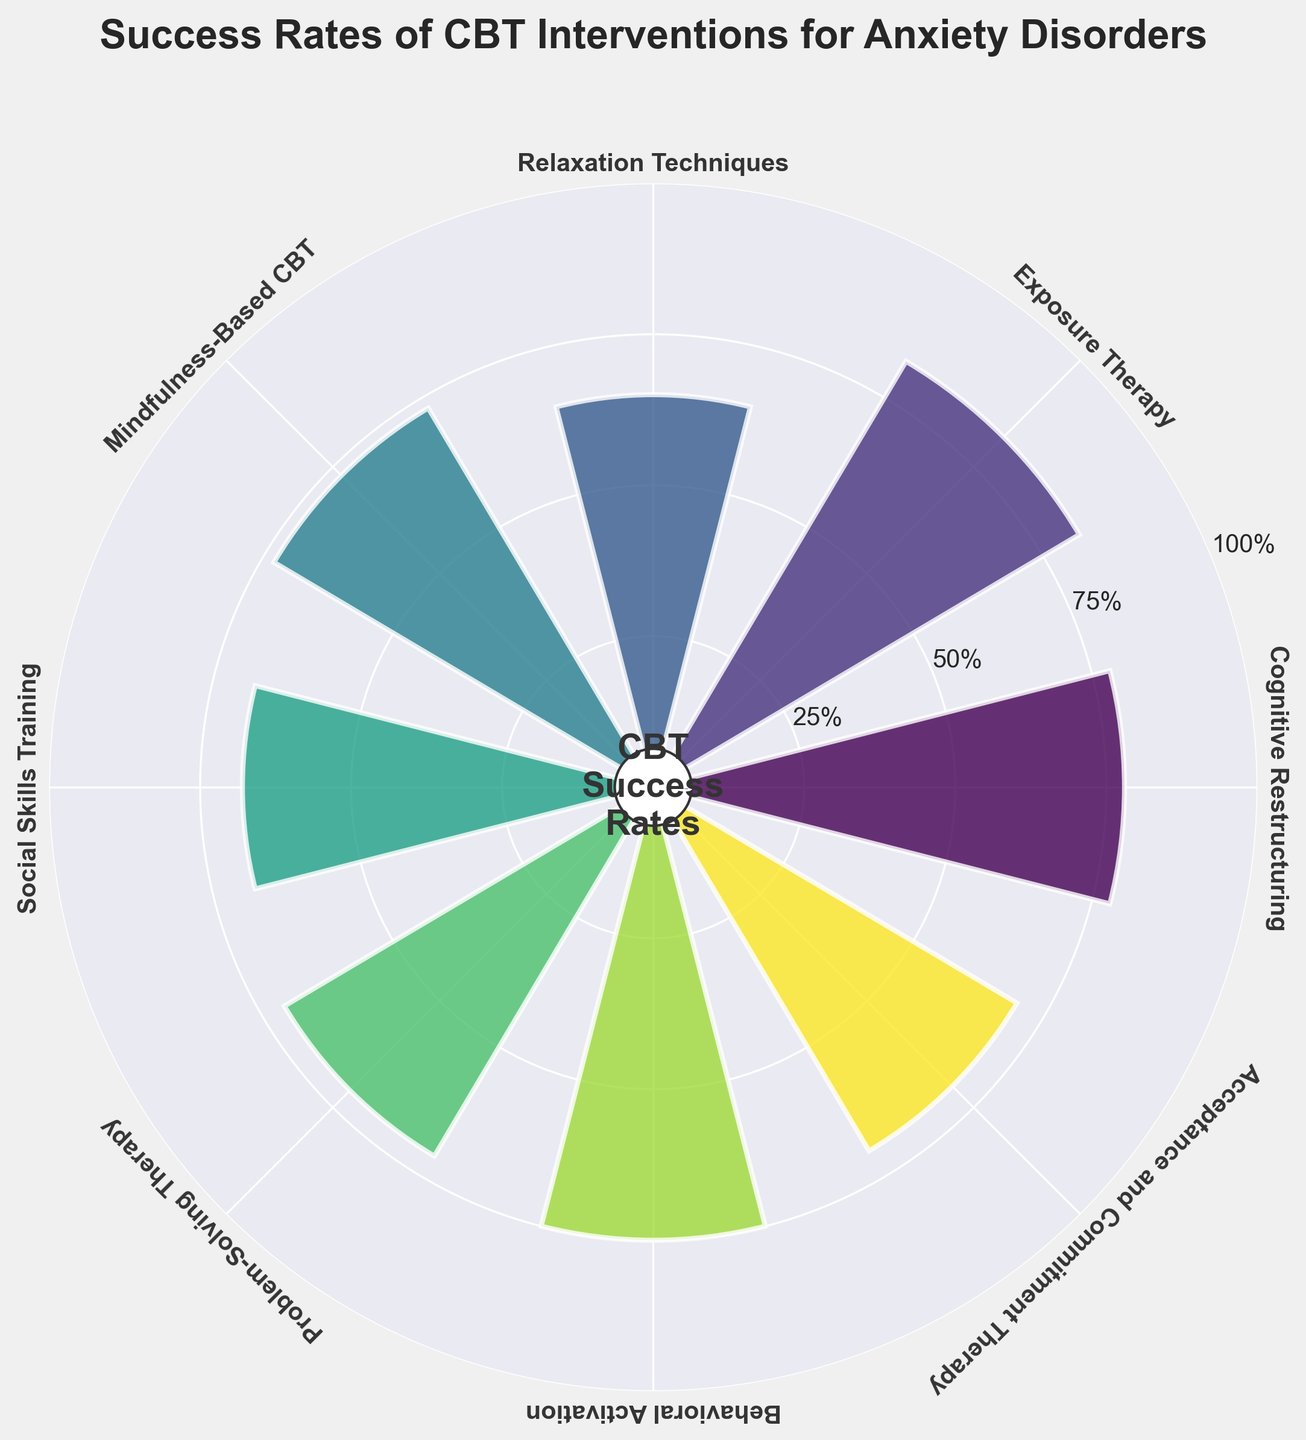What is the title of the gauge chart? The title is the descriptive heading at the top of the figure that summarizes the content of the chart. In this chart, it is bold and located above the chart.
Answer: Success Rates of CBT Interventions for Anxiety Disorders Which CBT intervention has the highest success rate? To find the highest success rate, you look for the label associated with the largest segment of the chart. In this case, the largest bar in the gauge at the highest position indicates the highest success rate.
Answer: Exposure Therapy What is the success rate of Relaxation Techniques? Look at the segment labeled "Relaxation Techniques" and check the length of the bar extending from the center. The rate is also indicated on the y-axis ticks where the bar ends.
Answer: 65% How many CBT interventions are displayed in the gauge chart? To determine this, count the individual segments or labels around the gauge chart. Every unique label represents a distinct CBT intervention.
Answer: 8 Which CBT intervention has a success rate closest to 75%? To find this, look at the height of the bars that are labeled with the success rates. The one closest to the 75% mark on the y-axis should be identified.
Answer: Behavioral Activation What is the difference in success rate between Social Skills Training and Cognitive Restructuring? To calculate this difference, subtract the success rate of Social Skills Training from Cognitive Restructuring.
Answer: 78% - 68% = 10% What is the average success rate of all the CBT interventions? To find the average, sum all the success rates and divide by the number of interventions. (78 + 82 + 65 + 73 + 68 + 71 + 75 + 70) / 8 = 582 / 8
Answer: 72.75% Which two CBT interventions have the closest success rates? Compare the success rates of all pairs of interventions to find the smallest difference. The closest pair would be the ones with nearly identical bar lengths.
Answer: Acceptance and Commitment Therapy (70%) and Problem-Solving Therapy (71%) Which intervention has a higher success rate: Mindfulness-Based CBT or Social Skills Training? Compare the success rates by looking at the height of their corresponding bars in the gauge chart.
Answer: Mindfulness-Based CBT What percentage of the interventions have a success rate of 70% or higher? Count the number of interventions with a success rate of at least 70%, and then divide by the total number of interventions, multiply by 100. (6 out of 8 interventions)
Answer: 75% 